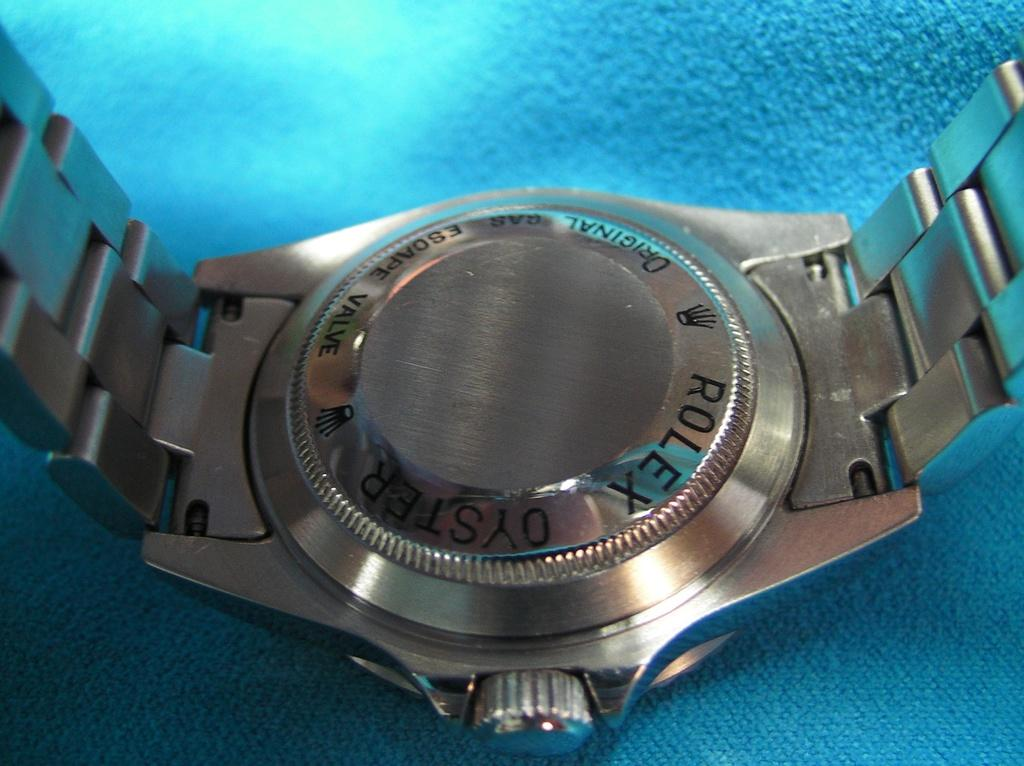<image>
Offer a succinct explanation of the picture presented. A silver Rolex watch is placed face down on a blue table. 